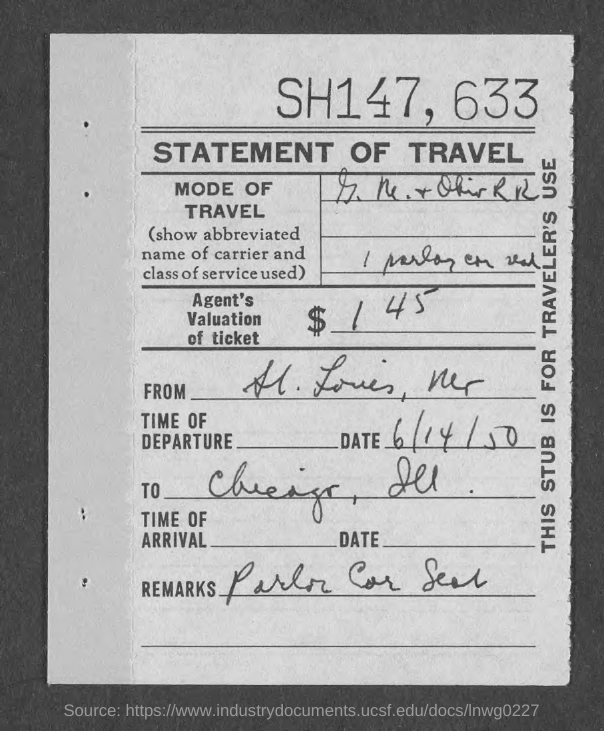Identify some key points in this picture. The number written at the top of the page is 633. The date provided is June 14th, 1950. 